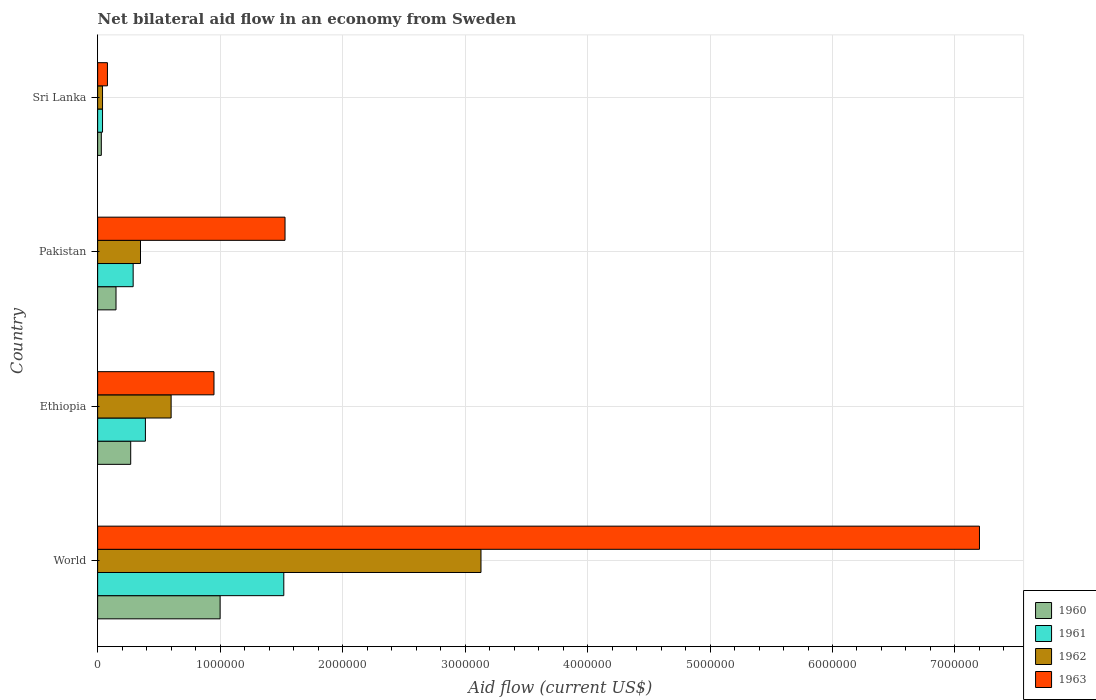Are the number of bars on each tick of the Y-axis equal?
Provide a short and direct response. Yes. How many bars are there on the 1st tick from the top?
Offer a very short reply. 4. How many bars are there on the 3rd tick from the bottom?
Offer a very short reply. 4. What is the label of the 2nd group of bars from the top?
Your answer should be very brief. Pakistan. What is the net bilateral aid flow in 1963 in Pakistan?
Your response must be concise. 1.53e+06. Across all countries, what is the maximum net bilateral aid flow in 1963?
Provide a succinct answer. 7.20e+06. Across all countries, what is the minimum net bilateral aid flow in 1961?
Give a very brief answer. 4.00e+04. In which country was the net bilateral aid flow in 1963 minimum?
Keep it short and to the point. Sri Lanka. What is the total net bilateral aid flow in 1962 in the graph?
Provide a short and direct response. 4.12e+06. What is the difference between the net bilateral aid flow in 1962 in Ethiopia and that in Sri Lanka?
Provide a succinct answer. 5.60e+05. What is the difference between the net bilateral aid flow in 1962 in Sri Lanka and the net bilateral aid flow in 1963 in Ethiopia?
Your answer should be compact. -9.10e+05. What is the average net bilateral aid flow in 1961 per country?
Offer a very short reply. 5.60e+05. What is the difference between the net bilateral aid flow in 1961 and net bilateral aid flow in 1962 in Sri Lanka?
Your answer should be very brief. 0. In how many countries, is the net bilateral aid flow in 1962 greater than 1800000 US$?
Offer a very short reply. 1. What is the ratio of the net bilateral aid flow in 1962 in Ethiopia to that in Pakistan?
Give a very brief answer. 1.71. Is the net bilateral aid flow in 1963 in Ethiopia less than that in Sri Lanka?
Give a very brief answer. No. What is the difference between the highest and the second highest net bilateral aid flow in 1962?
Provide a short and direct response. 2.53e+06. What is the difference between the highest and the lowest net bilateral aid flow in 1961?
Your answer should be very brief. 1.48e+06. Is it the case that in every country, the sum of the net bilateral aid flow in 1961 and net bilateral aid flow in 1962 is greater than the sum of net bilateral aid flow in 1963 and net bilateral aid flow in 1960?
Your answer should be compact. No. What does the 1st bar from the top in Ethiopia represents?
Give a very brief answer. 1963. How many bars are there?
Your answer should be compact. 16. What is the difference between two consecutive major ticks on the X-axis?
Your response must be concise. 1.00e+06. Are the values on the major ticks of X-axis written in scientific E-notation?
Offer a terse response. No. Does the graph contain grids?
Your answer should be compact. Yes. How many legend labels are there?
Your answer should be very brief. 4. What is the title of the graph?
Provide a short and direct response. Net bilateral aid flow in an economy from Sweden. Does "1974" appear as one of the legend labels in the graph?
Ensure brevity in your answer.  No. What is the label or title of the Y-axis?
Keep it short and to the point. Country. What is the Aid flow (current US$) of 1960 in World?
Offer a terse response. 1.00e+06. What is the Aid flow (current US$) of 1961 in World?
Your answer should be compact. 1.52e+06. What is the Aid flow (current US$) of 1962 in World?
Give a very brief answer. 3.13e+06. What is the Aid flow (current US$) in 1963 in World?
Offer a terse response. 7.20e+06. What is the Aid flow (current US$) in 1960 in Ethiopia?
Provide a succinct answer. 2.70e+05. What is the Aid flow (current US$) of 1961 in Ethiopia?
Your response must be concise. 3.90e+05. What is the Aid flow (current US$) of 1962 in Ethiopia?
Give a very brief answer. 6.00e+05. What is the Aid flow (current US$) of 1963 in Ethiopia?
Ensure brevity in your answer.  9.50e+05. What is the Aid flow (current US$) of 1961 in Pakistan?
Keep it short and to the point. 2.90e+05. What is the Aid flow (current US$) in 1963 in Pakistan?
Your response must be concise. 1.53e+06. What is the Aid flow (current US$) of 1960 in Sri Lanka?
Provide a short and direct response. 3.00e+04. What is the Aid flow (current US$) in 1961 in Sri Lanka?
Offer a very short reply. 4.00e+04. What is the Aid flow (current US$) of 1963 in Sri Lanka?
Give a very brief answer. 8.00e+04. Across all countries, what is the maximum Aid flow (current US$) in 1961?
Give a very brief answer. 1.52e+06. Across all countries, what is the maximum Aid flow (current US$) in 1962?
Your answer should be very brief. 3.13e+06. Across all countries, what is the maximum Aid flow (current US$) of 1963?
Ensure brevity in your answer.  7.20e+06. Across all countries, what is the minimum Aid flow (current US$) in 1960?
Your answer should be very brief. 3.00e+04. Across all countries, what is the minimum Aid flow (current US$) in 1962?
Offer a terse response. 4.00e+04. Across all countries, what is the minimum Aid flow (current US$) of 1963?
Your answer should be compact. 8.00e+04. What is the total Aid flow (current US$) in 1960 in the graph?
Your answer should be compact. 1.45e+06. What is the total Aid flow (current US$) of 1961 in the graph?
Provide a succinct answer. 2.24e+06. What is the total Aid flow (current US$) in 1962 in the graph?
Provide a succinct answer. 4.12e+06. What is the total Aid flow (current US$) in 1963 in the graph?
Your response must be concise. 9.76e+06. What is the difference between the Aid flow (current US$) in 1960 in World and that in Ethiopia?
Your answer should be compact. 7.30e+05. What is the difference between the Aid flow (current US$) in 1961 in World and that in Ethiopia?
Your answer should be very brief. 1.13e+06. What is the difference between the Aid flow (current US$) in 1962 in World and that in Ethiopia?
Ensure brevity in your answer.  2.53e+06. What is the difference between the Aid flow (current US$) of 1963 in World and that in Ethiopia?
Offer a very short reply. 6.25e+06. What is the difference between the Aid flow (current US$) in 1960 in World and that in Pakistan?
Offer a terse response. 8.50e+05. What is the difference between the Aid flow (current US$) of 1961 in World and that in Pakistan?
Provide a succinct answer. 1.23e+06. What is the difference between the Aid flow (current US$) in 1962 in World and that in Pakistan?
Make the answer very short. 2.78e+06. What is the difference between the Aid flow (current US$) in 1963 in World and that in Pakistan?
Your response must be concise. 5.67e+06. What is the difference between the Aid flow (current US$) of 1960 in World and that in Sri Lanka?
Offer a very short reply. 9.70e+05. What is the difference between the Aid flow (current US$) in 1961 in World and that in Sri Lanka?
Your answer should be compact. 1.48e+06. What is the difference between the Aid flow (current US$) of 1962 in World and that in Sri Lanka?
Ensure brevity in your answer.  3.09e+06. What is the difference between the Aid flow (current US$) of 1963 in World and that in Sri Lanka?
Ensure brevity in your answer.  7.12e+06. What is the difference between the Aid flow (current US$) in 1960 in Ethiopia and that in Pakistan?
Offer a terse response. 1.20e+05. What is the difference between the Aid flow (current US$) in 1962 in Ethiopia and that in Pakistan?
Provide a succinct answer. 2.50e+05. What is the difference between the Aid flow (current US$) in 1963 in Ethiopia and that in Pakistan?
Ensure brevity in your answer.  -5.80e+05. What is the difference between the Aid flow (current US$) of 1962 in Ethiopia and that in Sri Lanka?
Offer a very short reply. 5.60e+05. What is the difference between the Aid flow (current US$) in 1963 in Ethiopia and that in Sri Lanka?
Provide a succinct answer. 8.70e+05. What is the difference between the Aid flow (current US$) in 1961 in Pakistan and that in Sri Lanka?
Your answer should be very brief. 2.50e+05. What is the difference between the Aid flow (current US$) in 1962 in Pakistan and that in Sri Lanka?
Keep it short and to the point. 3.10e+05. What is the difference between the Aid flow (current US$) in 1963 in Pakistan and that in Sri Lanka?
Ensure brevity in your answer.  1.45e+06. What is the difference between the Aid flow (current US$) in 1960 in World and the Aid flow (current US$) in 1961 in Ethiopia?
Provide a succinct answer. 6.10e+05. What is the difference between the Aid flow (current US$) in 1960 in World and the Aid flow (current US$) in 1963 in Ethiopia?
Offer a terse response. 5.00e+04. What is the difference between the Aid flow (current US$) of 1961 in World and the Aid flow (current US$) of 1962 in Ethiopia?
Give a very brief answer. 9.20e+05. What is the difference between the Aid flow (current US$) in 1961 in World and the Aid flow (current US$) in 1963 in Ethiopia?
Give a very brief answer. 5.70e+05. What is the difference between the Aid flow (current US$) of 1962 in World and the Aid flow (current US$) of 1963 in Ethiopia?
Make the answer very short. 2.18e+06. What is the difference between the Aid flow (current US$) in 1960 in World and the Aid flow (current US$) in 1961 in Pakistan?
Ensure brevity in your answer.  7.10e+05. What is the difference between the Aid flow (current US$) in 1960 in World and the Aid flow (current US$) in 1962 in Pakistan?
Offer a very short reply. 6.50e+05. What is the difference between the Aid flow (current US$) of 1960 in World and the Aid flow (current US$) of 1963 in Pakistan?
Give a very brief answer. -5.30e+05. What is the difference between the Aid flow (current US$) in 1961 in World and the Aid flow (current US$) in 1962 in Pakistan?
Your response must be concise. 1.17e+06. What is the difference between the Aid flow (current US$) of 1962 in World and the Aid flow (current US$) of 1963 in Pakistan?
Give a very brief answer. 1.60e+06. What is the difference between the Aid flow (current US$) of 1960 in World and the Aid flow (current US$) of 1961 in Sri Lanka?
Make the answer very short. 9.60e+05. What is the difference between the Aid flow (current US$) in 1960 in World and the Aid flow (current US$) in 1962 in Sri Lanka?
Provide a short and direct response. 9.60e+05. What is the difference between the Aid flow (current US$) in 1960 in World and the Aid flow (current US$) in 1963 in Sri Lanka?
Provide a succinct answer. 9.20e+05. What is the difference between the Aid flow (current US$) of 1961 in World and the Aid flow (current US$) of 1962 in Sri Lanka?
Your answer should be compact. 1.48e+06. What is the difference between the Aid flow (current US$) of 1961 in World and the Aid flow (current US$) of 1963 in Sri Lanka?
Your answer should be compact. 1.44e+06. What is the difference between the Aid flow (current US$) in 1962 in World and the Aid flow (current US$) in 1963 in Sri Lanka?
Provide a short and direct response. 3.05e+06. What is the difference between the Aid flow (current US$) of 1960 in Ethiopia and the Aid flow (current US$) of 1963 in Pakistan?
Offer a terse response. -1.26e+06. What is the difference between the Aid flow (current US$) of 1961 in Ethiopia and the Aid flow (current US$) of 1963 in Pakistan?
Offer a very short reply. -1.14e+06. What is the difference between the Aid flow (current US$) of 1962 in Ethiopia and the Aid flow (current US$) of 1963 in Pakistan?
Provide a short and direct response. -9.30e+05. What is the difference between the Aid flow (current US$) in 1960 in Ethiopia and the Aid flow (current US$) in 1963 in Sri Lanka?
Give a very brief answer. 1.90e+05. What is the difference between the Aid flow (current US$) in 1961 in Ethiopia and the Aid flow (current US$) in 1963 in Sri Lanka?
Offer a terse response. 3.10e+05. What is the difference between the Aid flow (current US$) in 1962 in Ethiopia and the Aid flow (current US$) in 1963 in Sri Lanka?
Your answer should be very brief. 5.20e+05. What is the difference between the Aid flow (current US$) in 1960 in Pakistan and the Aid flow (current US$) in 1961 in Sri Lanka?
Offer a very short reply. 1.10e+05. What is the difference between the Aid flow (current US$) of 1960 in Pakistan and the Aid flow (current US$) of 1962 in Sri Lanka?
Make the answer very short. 1.10e+05. What is the difference between the Aid flow (current US$) in 1961 in Pakistan and the Aid flow (current US$) in 1962 in Sri Lanka?
Provide a succinct answer. 2.50e+05. What is the difference between the Aid flow (current US$) of 1961 in Pakistan and the Aid flow (current US$) of 1963 in Sri Lanka?
Provide a succinct answer. 2.10e+05. What is the average Aid flow (current US$) of 1960 per country?
Your answer should be compact. 3.62e+05. What is the average Aid flow (current US$) in 1961 per country?
Provide a short and direct response. 5.60e+05. What is the average Aid flow (current US$) in 1962 per country?
Give a very brief answer. 1.03e+06. What is the average Aid flow (current US$) of 1963 per country?
Your answer should be very brief. 2.44e+06. What is the difference between the Aid flow (current US$) in 1960 and Aid flow (current US$) in 1961 in World?
Your answer should be compact. -5.20e+05. What is the difference between the Aid flow (current US$) of 1960 and Aid flow (current US$) of 1962 in World?
Keep it short and to the point. -2.13e+06. What is the difference between the Aid flow (current US$) in 1960 and Aid flow (current US$) in 1963 in World?
Your answer should be compact. -6.20e+06. What is the difference between the Aid flow (current US$) in 1961 and Aid flow (current US$) in 1962 in World?
Your response must be concise. -1.61e+06. What is the difference between the Aid flow (current US$) of 1961 and Aid flow (current US$) of 1963 in World?
Offer a very short reply. -5.68e+06. What is the difference between the Aid flow (current US$) in 1962 and Aid flow (current US$) in 1963 in World?
Ensure brevity in your answer.  -4.07e+06. What is the difference between the Aid flow (current US$) in 1960 and Aid flow (current US$) in 1962 in Ethiopia?
Offer a very short reply. -3.30e+05. What is the difference between the Aid flow (current US$) of 1960 and Aid flow (current US$) of 1963 in Ethiopia?
Your answer should be compact. -6.80e+05. What is the difference between the Aid flow (current US$) of 1961 and Aid flow (current US$) of 1962 in Ethiopia?
Your answer should be very brief. -2.10e+05. What is the difference between the Aid flow (current US$) in 1961 and Aid flow (current US$) in 1963 in Ethiopia?
Offer a terse response. -5.60e+05. What is the difference between the Aid flow (current US$) of 1962 and Aid flow (current US$) of 1963 in Ethiopia?
Your answer should be very brief. -3.50e+05. What is the difference between the Aid flow (current US$) of 1960 and Aid flow (current US$) of 1961 in Pakistan?
Give a very brief answer. -1.40e+05. What is the difference between the Aid flow (current US$) in 1960 and Aid flow (current US$) in 1962 in Pakistan?
Offer a very short reply. -2.00e+05. What is the difference between the Aid flow (current US$) in 1960 and Aid flow (current US$) in 1963 in Pakistan?
Your response must be concise. -1.38e+06. What is the difference between the Aid flow (current US$) in 1961 and Aid flow (current US$) in 1962 in Pakistan?
Provide a short and direct response. -6.00e+04. What is the difference between the Aid flow (current US$) of 1961 and Aid flow (current US$) of 1963 in Pakistan?
Make the answer very short. -1.24e+06. What is the difference between the Aid flow (current US$) of 1962 and Aid flow (current US$) of 1963 in Pakistan?
Give a very brief answer. -1.18e+06. What is the difference between the Aid flow (current US$) in 1961 and Aid flow (current US$) in 1962 in Sri Lanka?
Offer a very short reply. 0. What is the difference between the Aid flow (current US$) in 1961 and Aid flow (current US$) in 1963 in Sri Lanka?
Make the answer very short. -4.00e+04. What is the difference between the Aid flow (current US$) in 1962 and Aid flow (current US$) in 1963 in Sri Lanka?
Your answer should be very brief. -4.00e+04. What is the ratio of the Aid flow (current US$) of 1960 in World to that in Ethiopia?
Provide a succinct answer. 3.7. What is the ratio of the Aid flow (current US$) of 1961 in World to that in Ethiopia?
Your answer should be very brief. 3.9. What is the ratio of the Aid flow (current US$) in 1962 in World to that in Ethiopia?
Your response must be concise. 5.22. What is the ratio of the Aid flow (current US$) in 1963 in World to that in Ethiopia?
Your answer should be compact. 7.58. What is the ratio of the Aid flow (current US$) of 1961 in World to that in Pakistan?
Your response must be concise. 5.24. What is the ratio of the Aid flow (current US$) in 1962 in World to that in Pakistan?
Make the answer very short. 8.94. What is the ratio of the Aid flow (current US$) of 1963 in World to that in Pakistan?
Your response must be concise. 4.71. What is the ratio of the Aid flow (current US$) of 1960 in World to that in Sri Lanka?
Your answer should be compact. 33.33. What is the ratio of the Aid flow (current US$) in 1962 in World to that in Sri Lanka?
Provide a succinct answer. 78.25. What is the ratio of the Aid flow (current US$) in 1960 in Ethiopia to that in Pakistan?
Provide a short and direct response. 1.8. What is the ratio of the Aid flow (current US$) of 1961 in Ethiopia to that in Pakistan?
Offer a terse response. 1.34. What is the ratio of the Aid flow (current US$) in 1962 in Ethiopia to that in Pakistan?
Provide a succinct answer. 1.71. What is the ratio of the Aid flow (current US$) of 1963 in Ethiopia to that in Pakistan?
Make the answer very short. 0.62. What is the ratio of the Aid flow (current US$) of 1960 in Ethiopia to that in Sri Lanka?
Make the answer very short. 9. What is the ratio of the Aid flow (current US$) of 1961 in Ethiopia to that in Sri Lanka?
Your response must be concise. 9.75. What is the ratio of the Aid flow (current US$) in 1962 in Ethiopia to that in Sri Lanka?
Your answer should be very brief. 15. What is the ratio of the Aid flow (current US$) of 1963 in Ethiopia to that in Sri Lanka?
Provide a short and direct response. 11.88. What is the ratio of the Aid flow (current US$) in 1961 in Pakistan to that in Sri Lanka?
Provide a short and direct response. 7.25. What is the ratio of the Aid flow (current US$) in 1962 in Pakistan to that in Sri Lanka?
Your answer should be very brief. 8.75. What is the ratio of the Aid flow (current US$) of 1963 in Pakistan to that in Sri Lanka?
Offer a terse response. 19.12. What is the difference between the highest and the second highest Aid flow (current US$) in 1960?
Provide a short and direct response. 7.30e+05. What is the difference between the highest and the second highest Aid flow (current US$) of 1961?
Provide a short and direct response. 1.13e+06. What is the difference between the highest and the second highest Aid flow (current US$) of 1962?
Make the answer very short. 2.53e+06. What is the difference between the highest and the second highest Aid flow (current US$) of 1963?
Make the answer very short. 5.67e+06. What is the difference between the highest and the lowest Aid flow (current US$) of 1960?
Give a very brief answer. 9.70e+05. What is the difference between the highest and the lowest Aid flow (current US$) in 1961?
Your response must be concise. 1.48e+06. What is the difference between the highest and the lowest Aid flow (current US$) of 1962?
Provide a succinct answer. 3.09e+06. What is the difference between the highest and the lowest Aid flow (current US$) in 1963?
Provide a short and direct response. 7.12e+06. 